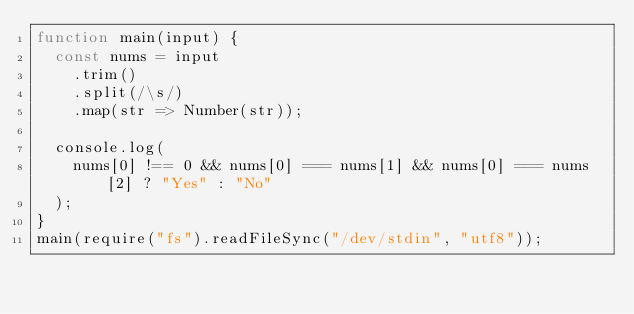<code> <loc_0><loc_0><loc_500><loc_500><_JavaScript_>function main(input) {
  const nums = input
    .trim()
    .split(/\s/)
    .map(str => Number(str));

  console.log(
    nums[0] !== 0 && nums[0] === nums[1] && nums[0] === nums[2] ? "Yes" : "No"
  );
}
main(require("fs").readFileSync("/dev/stdin", "utf8"));
</code> 